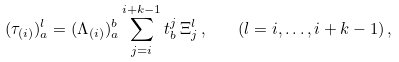Convert formula to latex. <formula><loc_0><loc_0><loc_500><loc_500>( \tau _ { ( i ) } ) _ { a } ^ { l } = ( \Lambda _ { ( i ) } ) _ { a } ^ { b } \sum _ { j = i } ^ { i + k - 1 } t _ { b } ^ { j } \, \Xi _ { j } ^ { l } \, , \quad ( l = i , \dots , i + k - 1 ) \, ,</formula> 